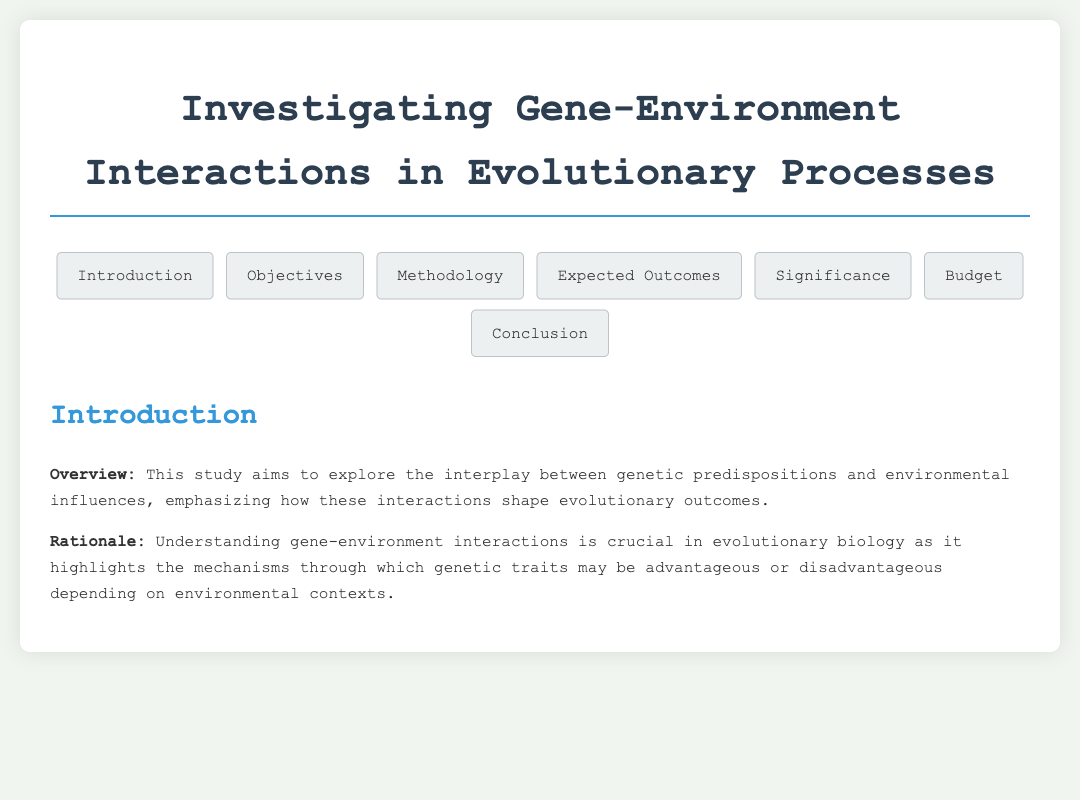What is the total budget for the project? The total budget is stated in the budget section of the document.
Answer: $250,000 What methodology is used for data collection? The methodology mentions specific methods used for gathering data in the study.
Answer: Genomic sequencing, environmental sampling, phenotypic assessments What are the expected outcomes of the study? The expected outcomes are outlined in a section dedicated to anticipated results of the research.
Answer: Identification of critical gene-environment interactions What significance does this research have according to the proposal? The significance details the theoretical and practical implications of the study.
Answer: Evidence supporting genes as primary drivers of evolution What is one of the objectives of the study? Objectives are listed in a bullet format in the objectives section of the document.
Answer: Identify specific gene variants What type of study design is utilized? The study design is specified in the methodology section, highlighting the approach taken.
Answer: Longitudinal study What is the focus of the introduction section? The introduction section provides an overview and rationale for the study’s importance.
Answer: Gene-environment interactions in evolutionary outcomes Which high-impact journals are mentioned for potential publications? The expected outcomes of the research include specific journals for potential articles.
Answer: Nature Genetics and Evolution 